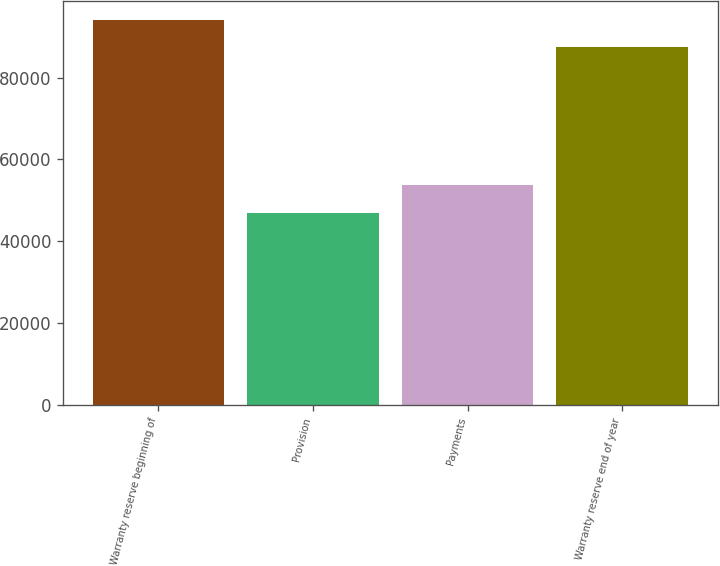Convert chart to OTSL. <chart><loc_0><loc_0><loc_500><loc_500><bar_chart><fcel>Warranty reserve beginning of<fcel>Provision<fcel>Payments<fcel>Warranty reserve end of year<nl><fcel>94060<fcel>47003<fcel>53656<fcel>87407<nl></chart> 